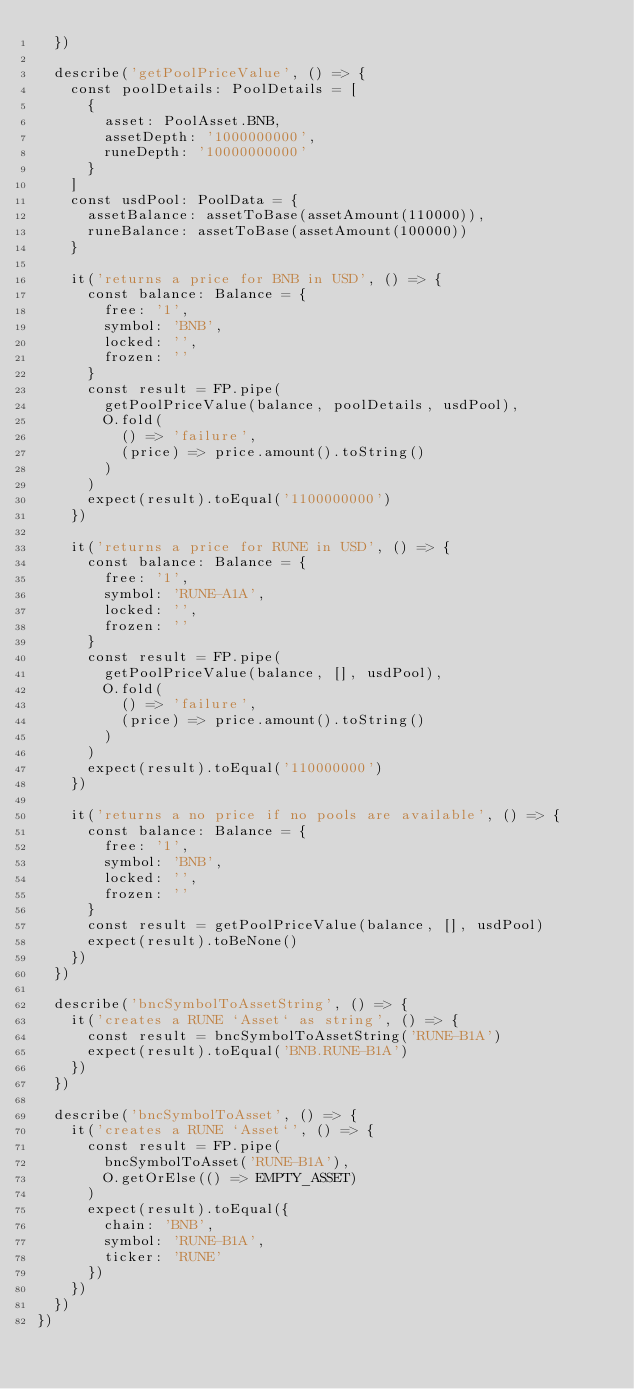<code> <loc_0><loc_0><loc_500><loc_500><_TypeScript_>  })

  describe('getPoolPriceValue', () => {
    const poolDetails: PoolDetails = [
      {
        asset: PoolAsset.BNB,
        assetDepth: '1000000000',
        runeDepth: '10000000000'
      }
    ]
    const usdPool: PoolData = {
      assetBalance: assetToBase(assetAmount(110000)),
      runeBalance: assetToBase(assetAmount(100000))
    }

    it('returns a price for BNB in USD', () => {
      const balance: Balance = {
        free: '1',
        symbol: 'BNB',
        locked: '',
        frozen: ''
      }
      const result = FP.pipe(
        getPoolPriceValue(balance, poolDetails, usdPool),
        O.fold(
          () => 'failure',
          (price) => price.amount().toString()
        )
      )
      expect(result).toEqual('1100000000')
    })

    it('returns a price for RUNE in USD', () => {
      const balance: Balance = {
        free: '1',
        symbol: 'RUNE-A1A',
        locked: '',
        frozen: ''
      }
      const result = FP.pipe(
        getPoolPriceValue(balance, [], usdPool),
        O.fold(
          () => 'failure',
          (price) => price.amount().toString()
        )
      )
      expect(result).toEqual('110000000')
    })

    it('returns a no price if no pools are available', () => {
      const balance: Balance = {
        free: '1',
        symbol: 'BNB',
        locked: '',
        frozen: ''
      }
      const result = getPoolPriceValue(balance, [], usdPool)
      expect(result).toBeNone()
    })
  })

  describe('bncSymbolToAssetString', () => {
    it('creates a RUNE `Asset` as string', () => {
      const result = bncSymbolToAssetString('RUNE-B1A')
      expect(result).toEqual('BNB.RUNE-B1A')
    })
  })

  describe('bncSymbolToAsset', () => {
    it('creates a RUNE `Asset`', () => {
      const result = FP.pipe(
        bncSymbolToAsset('RUNE-B1A'),
        O.getOrElse(() => EMPTY_ASSET)
      )
      expect(result).toEqual({
        chain: 'BNB',
        symbol: 'RUNE-B1A',
        ticker: 'RUNE'
      })
    })
  })
})
</code> 